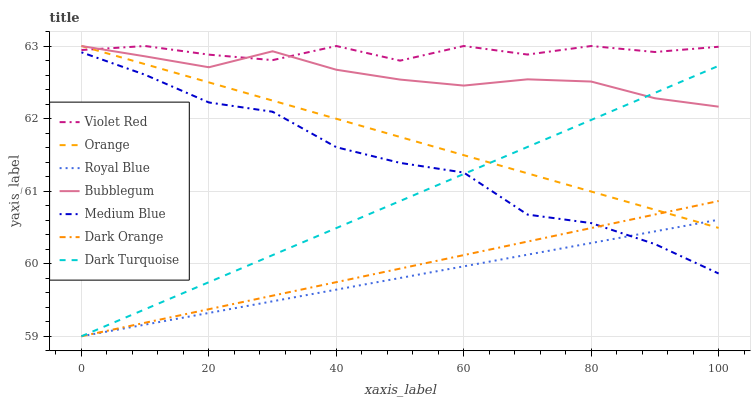Does Royal Blue have the minimum area under the curve?
Answer yes or no. Yes. Does Dark Turquoise have the minimum area under the curve?
Answer yes or no. No. Does Dark Turquoise have the maximum area under the curve?
Answer yes or no. No. Is Violet Red the smoothest?
Answer yes or no. No. Is Violet Red the roughest?
Answer yes or no. No. Does Violet Red have the lowest value?
Answer yes or no. No. Does Dark Turquoise have the highest value?
Answer yes or no. No. Is Medium Blue less than Bubblegum?
Answer yes or no. Yes. Is Violet Red greater than Medium Blue?
Answer yes or no. Yes. Does Medium Blue intersect Bubblegum?
Answer yes or no. No. 